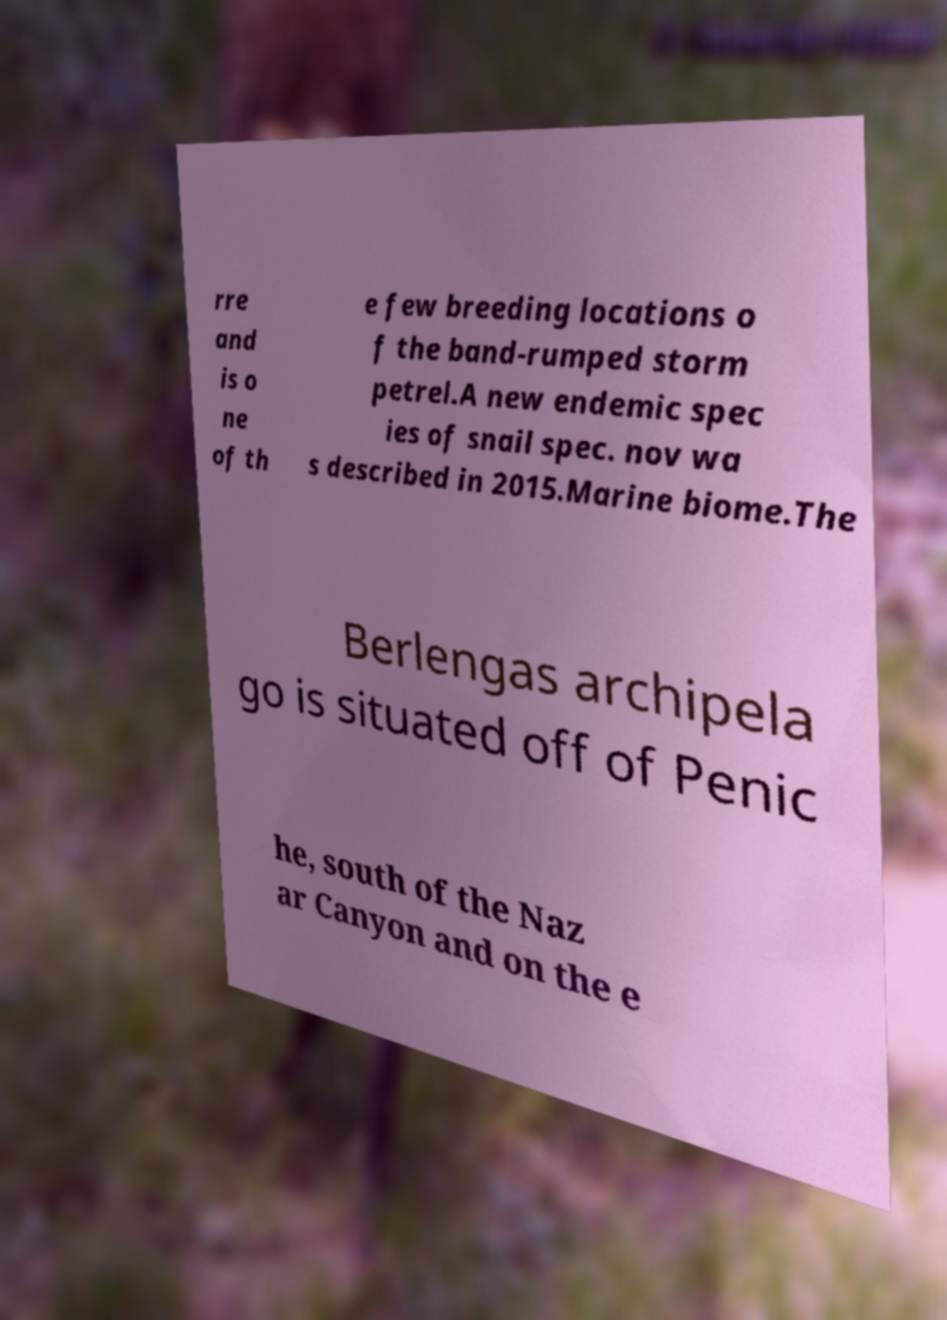What messages or text are displayed in this image? I need them in a readable, typed format. rre and is o ne of th e few breeding locations o f the band-rumped storm petrel.A new endemic spec ies of snail spec. nov wa s described in 2015.Marine biome.The Berlengas archipela go is situated off of Penic he, south of the Naz ar Canyon and on the e 